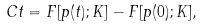<formula> <loc_0><loc_0><loc_500><loc_500>C t = F [ p ( t ) ; K ] - F [ p ( 0 ) ; K ] ,</formula> 